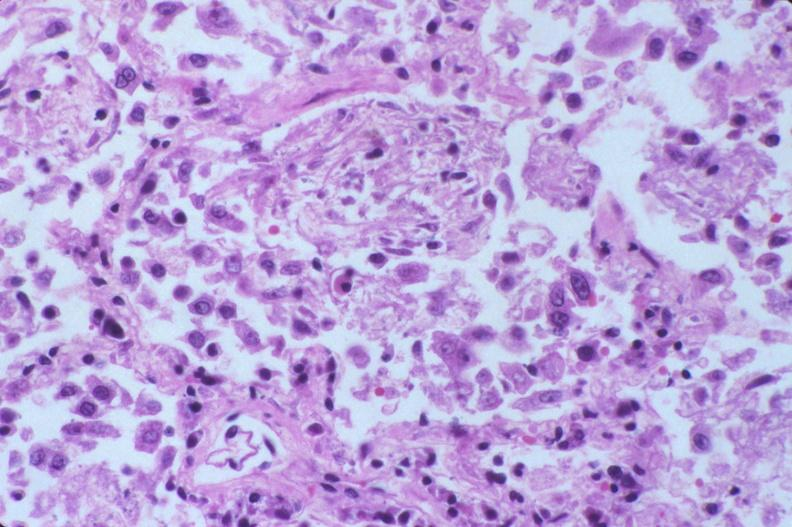where is this?
Answer the question using a single word or phrase. Lung 